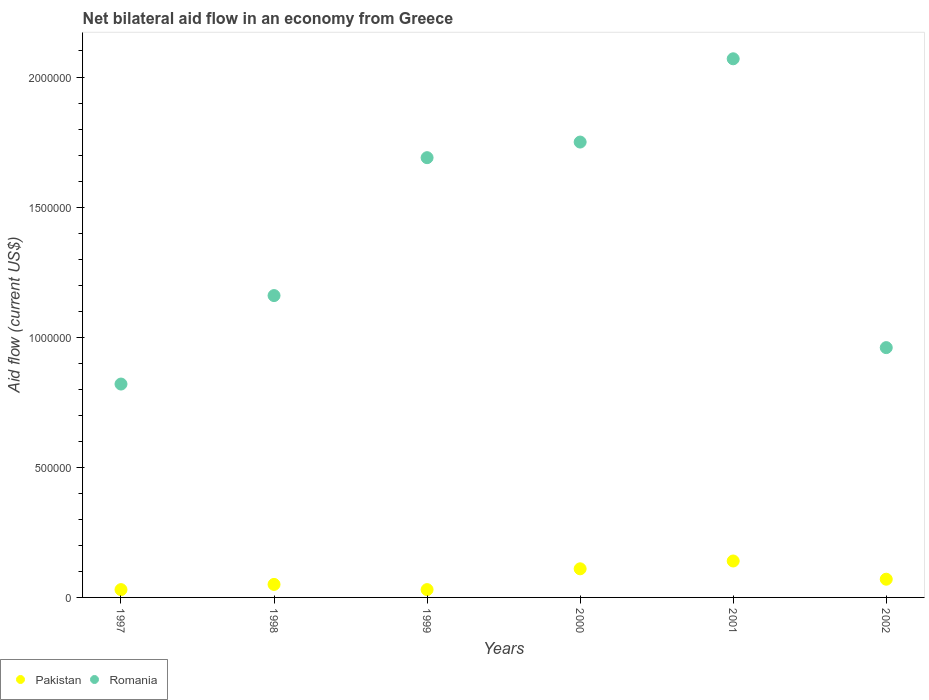How many different coloured dotlines are there?
Ensure brevity in your answer.  2. Is the number of dotlines equal to the number of legend labels?
Your response must be concise. Yes. What is the net bilateral aid flow in Pakistan in 1997?
Offer a very short reply. 3.00e+04. Across all years, what is the maximum net bilateral aid flow in Romania?
Give a very brief answer. 2.07e+06. In which year was the net bilateral aid flow in Romania maximum?
Provide a short and direct response. 2001. What is the difference between the net bilateral aid flow in Romania in 1997 and the net bilateral aid flow in Pakistan in 2001?
Your response must be concise. 6.80e+05. What is the average net bilateral aid flow in Romania per year?
Provide a succinct answer. 1.41e+06. In the year 2000, what is the difference between the net bilateral aid flow in Romania and net bilateral aid flow in Pakistan?
Offer a terse response. 1.64e+06. What is the ratio of the net bilateral aid flow in Romania in 1997 to that in 1998?
Your answer should be compact. 0.71. What is the difference between the highest and the second highest net bilateral aid flow in Romania?
Offer a terse response. 3.20e+05. What is the difference between the highest and the lowest net bilateral aid flow in Romania?
Give a very brief answer. 1.25e+06. In how many years, is the net bilateral aid flow in Pakistan greater than the average net bilateral aid flow in Pakistan taken over all years?
Provide a succinct answer. 2. Is the net bilateral aid flow in Pakistan strictly less than the net bilateral aid flow in Romania over the years?
Give a very brief answer. Yes. How many dotlines are there?
Give a very brief answer. 2. Are the values on the major ticks of Y-axis written in scientific E-notation?
Your answer should be compact. No. Does the graph contain any zero values?
Ensure brevity in your answer.  No. Does the graph contain grids?
Your answer should be compact. No. Where does the legend appear in the graph?
Provide a short and direct response. Bottom left. What is the title of the graph?
Provide a short and direct response. Net bilateral aid flow in an economy from Greece. Does "Uruguay" appear as one of the legend labels in the graph?
Your answer should be very brief. No. What is the label or title of the X-axis?
Ensure brevity in your answer.  Years. What is the Aid flow (current US$) in Pakistan in 1997?
Ensure brevity in your answer.  3.00e+04. What is the Aid flow (current US$) of Romania in 1997?
Provide a short and direct response. 8.20e+05. What is the Aid flow (current US$) in Romania in 1998?
Keep it short and to the point. 1.16e+06. What is the Aid flow (current US$) in Pakistan in 1999?
Offer a terse response. 3.00e+04. What is the Aid flow (current US$) of Romania in 1999?
Make the answer very short. 1.69e+06. What is the Aid flow (current US$) of Pakistan in 2000?
Make the answer very short. 1.10e+05. What is the Aid flow (current US$) in Romania in 2000?
Ensure brevity in your answer.  1.75e+06. What is the Aid flow (current US$) in Romania in 2001?
Your answer should be very brief. 2.07e+06. What is the Aid flow (current US$) in Pakistan in 2002?
Keep it short and to the point. 7.00e+04. What is the Aid flow (current US$) in Romania in 2002?
Offer a terse response. 9.60e+05. Across all years, what is the maximum Aid flow (current US$) of Pakistan?
Provide a succinct answer. 1.40e+05. Across all years, what is the maximum Aid flow (current US$) in Romania?
Make the answer very short. 2.07e+06. Across all years, what is the minimum Aid flow (current US$) of Pakistan?
Offer a very short reply. 3.00e+04. Across all years, what is the minimum Aid flow (current US$) of Romania?
Provide a succinct answer. 8.20e+05. What is the total Aid flow (current US$) in Romania in the graph?
Provide a succinct answer. 8.45e+06. What is the difference between the Aid flow (current US$) in Pakistan in 1997 and that in 1998?
Provide a succinct answer. -2.00e+04. What is the difference between the Aid flow (current US$) in Pakistan in 1997 and that in 1999?
Give a very brief answer. 0. What is the difference between the Aid flow (current US$) in Romania in 1997 and that in 1999?
Give a very brief answer. -8.70e+05. What is the difference between the Aid flow (current US$) of Romania in 1997 and that in 2000?
Give a very brief answer. -9.30e+05. What is the difference between the Aid flow (current US$) of Romania in 1997 and that in 2001?
Offer a very short reply. -1.25e+06. What is the difference between the Aid flow (current US$) of Pakistan in 1997 and that in 2002?
Provide a short and direct response. -4.00e+04. What is the difference between the Aid flow (current US$) of Romania in 1997 and that in 2002?
Give a very brief answer. -1.40e+05. What is the difference between the Aid flow (current US$) of Pakistan in 1998 and that in 1999?
Your answer should be compact. 2.00e+04. What is the difference between the Aid flow (current US$) in Romania in 1998 and that in 1999?
Give a very brief answer. -5.30e+05. What is the difference between the Aid flow (current US$) of Romania in 1998 and that in 2000?
Provide a succinct answer. -5.90e+05. What is the difference between the Aid flow (current US$) of Pakistan in 1998 and that in 2001?
Keep it short and to the point. -9.00e+04. What is the difference between the Aid flow (current US$) in Romania in 1998 and that in 2001?
Your answer should be compact. -9.10e+05. What is the difference between the Aid flow (current US$) in Pakistan in 1999 and that in 2001?
Your answer should be compact. -1.10e+05. What is the difference between the Aid flow (current US$) of Romania in 1999 and that in 2001?
Your response must be concise. -3.80e+05. What is the difference between the Aid flow (current US$) of Pakistan in 1999 and that in 2002?
Provide a short and direct response. -4.00e+04. What is the difference between the Aid flow (current US$) in Romania in 1999 and that in 2002?
Make the answer very short. 7.30e+05. What is the difference between the Aid flow (current US$) of Romania in 2000 and that in 2001?
Provide a short and direct response. -3.20e+05. What is the difference between the Aid flow (current US$) in Pakistan in 2000 and that in 2002?
Offer a terse response. 4.00e+04. What is the difference between the Aid flow (current US$) in Romania in 2000 and that in 2002?
Your response must be concise. 7.90e+05. What is the difference between the Aid flow (current US$) in Romania in 2001 and that in 2002?
Make the answer very short. 1.11e+06. What is the difference between the Aid flow (current US$) in Pakistan in 1997 and the Aid flow (current US$) in Romania in 1998?
Provide a short and direct response. -1.13e+06. What is the difference between the Aid flow (current US$) of Pakistan in 1997 and the Aid flow (current US$) of Romania in 1999?
Your answer should be very brief. -1.66e+06. What is the difference between the Aid flow (current US$) of Pakistan in 1997 and the Aid flow (current US$) of Romania in 2000?
Your answer should be compact. -1.72e+06. What is the difference between the Aid flow (current US$) of Pakistan in 1997 and the Aid flow (current US$) of Romania in 2001?
Your response must be concise. -2.04e+06. What is the difference between the Aid flow (current US$) of Pakistan in 1997 and the Aid flow (current US$) of Romania in 2002?
Give a very brief answer. -9.30e+05. What is the difference between the Aid flow (current US$) in Pakistan in 1998 and the Aid flow (current US$) in Romania in 1999?
Give a very brief answer. -1.64e+06. What is the difference between the Aid flow (current US$) in Pakistan in 1998 and the Aid flow (current US$) in Romania in 2000?
Your answer should be compact. -1.70e+06. What is the difference between the Aid flow (current US$) in Pakistan in 1998 and the Aid flow (current US$) in Romania in 2001?
Offer a very short reply. -2.02e+06. What is the difference between the Aid flow (current US$) of Pakistan in 1998 and the Aid flow (current US$) of Romania in 2002?
Your answer should be very brief. -9.10e+05. What is the difference between the Aid flow (current US$) of Pakistan in 1999 and the Aid flow (current US$) of Romania in 2000?
Ensure brevity in your answer.  -1.72e+06. What is the difference between the Aid flow (current US$) in Pakistan in 1999 and the Aid flow (current US$) in Romania in 2001?
Keep it short and to the point. -2.04e+06. What is the difference between the Aid flow (current US$) of Pakistan in 1999 and the Aid flow (current US$) of Romania in 2002?
Offer a terse response. -9.30e+05. What is the difference between the Aid flow (current US$) of Pakistan in 2000 and the Aid flow (current US$) of Romania in 2001?
Give a very brief answer. -1.96e+06. What is the difference between the Aid flow (current US$) of Pakistan in 2000 and the Aid flow (current US$) of Romania in 2002?
Offer a very short reply. -8.50e+05. What is the difference between the Aid flow (current US$) in Pakistan in 2001 and the Aid flow (current US$) in Romania in 2002?
Provide a succinct answer. -8.20e+05. What is the average Aid flow (current US$) of Pakistan per year?
Offer a very short reply. 7.17e+04. What is the average Aid flow (current US$) in Romania per year?
Give a very brief answer. 1.41e+06. In the year 1997, what is the difference between the Aid flow (current US$) of Pakistan and Aid flow (current US$) of Romania?
Your response must be concise. -7.90e+05. In the year 1998, what is the difference between the Aid flow (current US$) in Pakistan and Aid flow (current US$) in Romania?
Your answer should be compact. -1.11e+06. In the year 1999, what is the difference between the Aid flow (current US$) of Pakistan and Aid flow (current US$) of Romania?
Keep it short and to the point. -1.66e+06. In the year 2000, what is the difference between the Aid flow (current US$) of Pakistan and Aid flow (current US$) of Romania?
Your answer should be very brief. -1.64e+06. In the year 2001, what is the difference between the Aid flow (current US$) in Pakistan and Aid flow (current US$) in Romania?
Offer a very short reply. -1.93e+06. In the year 2002, what is the difference between the Aid flow (current US$) of Pakistan and Aid flow (current US$) of Romania?
Ensure brevity in your answer.  -8.90e+05. What is the ratio of the Aid flow (current US$) of Romania in 1997 to that in 1998?
Your answer should be compact. 0.71. What is the ratio of the Aid flow (current US$) of Pakistan in 1997 to that in 1999?
Provide a succinct answer. 1. What is the ratio of the Aid flow (current US$) of Romania in 1997 to that in 1999?
Your answer should be very brief. 0.49. What is the ratio of the Aid flow (current US$) of Pakistan in 1997 to that in 2000?
Provide a succinct answer. 0.27. What is the ratio of the Aid flow (current US$) of Romania in 1997 to that in 2000?
Your answer should be very brief. 0.47. What is the ratio of the Aid flow (current US$) in Pakistan in 1997 to that in 2001?
Offer a terse response. 0.21. What is the ratio of the Aid flow (current US$) in Romania in 1997 to that in 2001?
Give a very brief answer. 0.4. What is the ratio of the Aid flow (current US$) in Pakistan in 1997 to that in 2002?
Give a very brief answer. 0.43. What is the ratio of the Aid flow (current US$) in Romania in 1997 to that in 2002?
Provide a succinct answer. 0.85. What is the ratio of the Aid flow (current US$) of Romania in 1998 to that in 1999?
Give a very brief answer. 0.69. What is the ratio of the Aid flow (current US$) of Pakistan in 1998 to that in 2000?
Ensure brevity in your answer.  0.45. What is the ratio of the Aid flow (current US$) in Romania in 1998 to that in 2000?
Your response must be concise. 0.66. What is the ratio of the Aid flow (current US$) of Pakistan in 1998 to that in 2001?
Keep it short and to the point. 0.36. What is the ratio of the Aid flow (current US$) of Romania in 1998 to that in 2001?
Offer a very short reply. 0.56. What is the ratio of the Aid flow (current US$) in Romania in 1998 to that in 2002?
Your answer should be compact. 1.21. What is the ratio of the Aid flow (current US$) in Pakistan in 1999 to that in 2000?
Give a very brief answer. 0.27. What is the ratio of the Aid flow (current US$) in Romania in 1999 to that in 2000?
Your answer should be very brief. 0.97. What is the ratio of the Aid flow (current US$) of Pakistan in 1999 to that in 2001?
Your answer should be very brief. 0.21. What is the ratio of the Aid flow (current US$) of Romania in 1999 to that in 2001?
Keep it short and to the point. 0.82. What is the ratio of the Aid flow (current US$) in Pakistan in 1999 to that in 2002?
Offer a terse response. 0.43. What is the ratio of the Aid flow (current US$) of Romania in 1999 to that in 2002?
Your answer should be compact. 1.76. What is the ratio of the Aid flow (current US$) in Pakistan in 2000 to that in 2001?
Keep it short and to the point. 0.79. What is the ratio of the Aid flow (current US$) of Romania in 2000 to that in 2001?
Ensure brevity in your answer.  0.85. What is the ratio of the Aid flow (current US$) in Pakistan in 2000 to that in 2002?
Make the answer very short. 1.57. What is the ratio of the Aid flow (current US$) in Romania in 2000 to that in 2002?
Ensure brevity in your answer.  1.82. What is the ratio of the Aid flow (current US$) of Pakistan in 2001 to that in 2002?
Offer a very short reply. 2. What is the ratio of the Aid flow (current US$) of Romania in 2001 to that in 2002?
Provide a succinct answer. 2.16. What is the difference between the highest and the lowest Aid flow (current US$) in Romania?
Provide a succinct answer. 1.25e+06. 